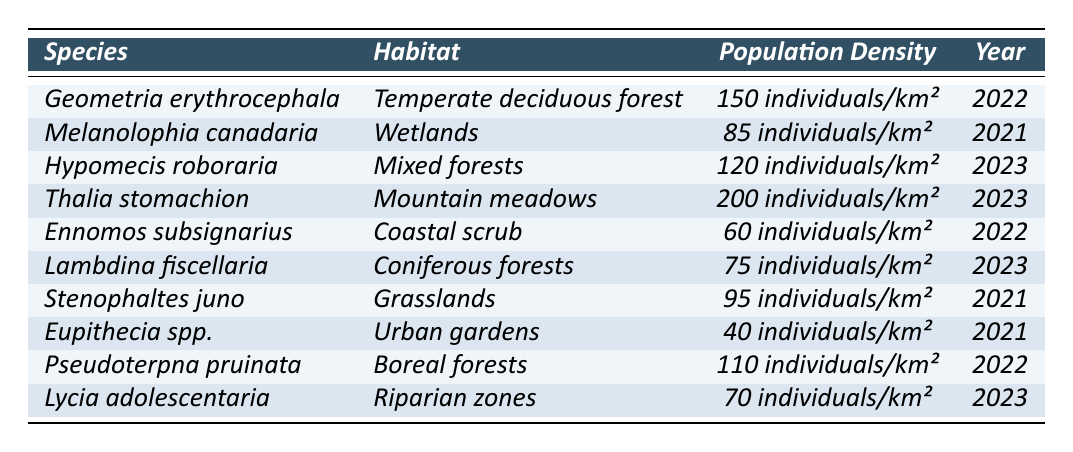What is the population density of *Geometria erythrocephala*? According to the table, the population density for *Geometria erythrocephala* is listed as 150 individuals/km².
Answer: 150 individuals/km² Which species has the highest population density? By analyzing the population densities listed in the table, *Thalia stomachion* has the highest density at 200 individuals/km².
Answer: *Thalia stomachion* How many species have a population density below 100 individuals/km²? The table shows three species with a population density below 100 individuals/km²: *Ennomos subsignarius* (60), *Lambdina fiscellaria* (75), and *Eupithecia spp.* (40), totaling three species.
Answer: 3 species What habitat is associated with *Hypomecis roboraria*? The table indicates that *Hypomecis roboraria* is found in the habitat classified as Mixed forests.
Answer: Mixed forests What is the average population density of the species observed in 2023? The species observed in 2023 are *Hypomecis roboraria* (120), *Thalia stomachion* (200), *Lambdina fiscellaria* (75), and *Lycia adolescentaria* (70). The sum is (120 + 200 + 75 + 70) = 465, and the average is 465/4 = 116.25 individuals/km².
Answer: 116.25 individuals/km² Is the population density of *Eupithecia spp.* higher than that of *Stenophaltes juno*? According to the table, *Eupithecia spp.* has a population density of 40 individuals/km², while *Stenophaltes juno* has 95 individuals/km², making the statement false.
Answer: No Which habitat supports the lowest population density based on the data? From the table, *Eupithecia spp.* is in Urban gardens and supports the lowest population density of 40 individuals/km² among the species listed.
Answer: Urban gardens If you combined the populations of *Melanolophia canadaria* and *Pseudoterpna pruinata*, what would their total density be? The population densities are 85 individuals/km² for *Melanolophia canadaria* and 110 individuals/km² for *Pseudoterpna pruinata*. Adding these gives 85 + 110 = 195 individuals/km².
Answer: 195 individuals/km² What year was *Thalia stomachion* observed? The table specifies that *Thalia stomachion* was observed in the year 2023.
Answer: 2023 How many different habitats are represented in the table? The table lists 10 different species across various habitats, including Temperate deciduous forest, Wetlands, Mixed forests, Mountain meadows, Coastal scrub, Coniferous forests, Grasslands, Urban gardens, and Boreal forests, totaling 9 unique habitats.
Answer: 9 habitats 